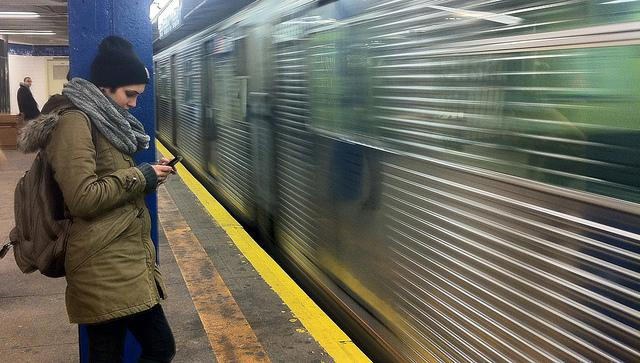What tells people where to stand for safety?

Choices:
A) garbage can
B) yellow line
C) train
D) blue column yellow line 